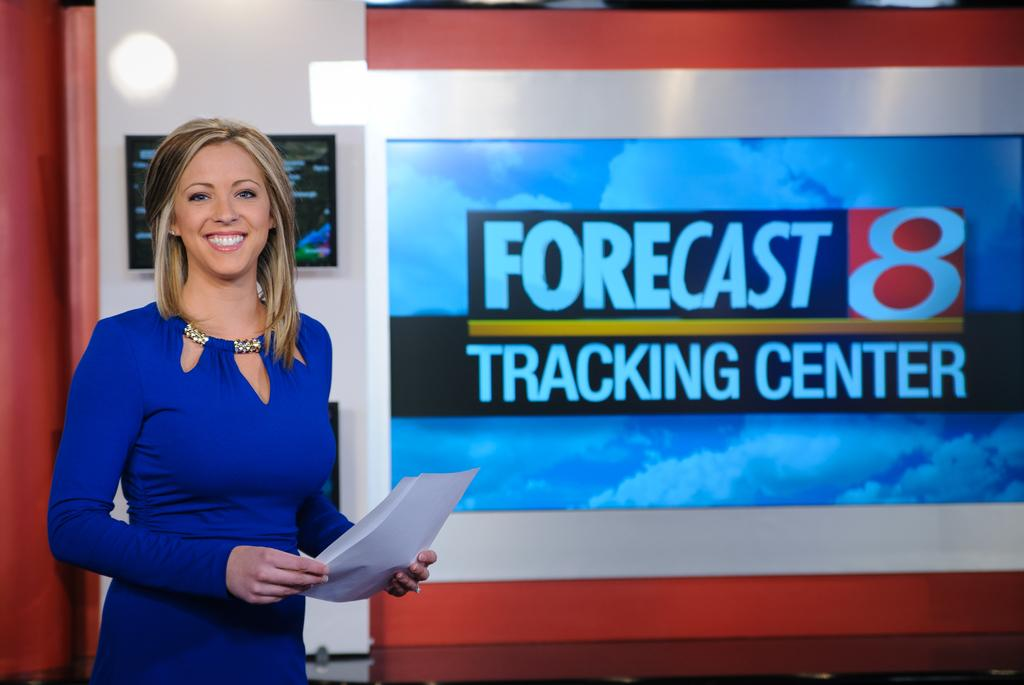Who is present in the image? There is a person in the image. What is the person wearing? The person is wearing a blue dress. What is the person holding? The person is holding papers. What can be seen in the background of the image? There is a screen and a wall with a white and red color scheme in the background. Can you see the person's eye in the image? The image does not show the person's eye; it only shows the person's body from the waist up. 